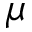Convert formula to latex. <formula><loc_0><loc_0><loc_500><loc_500>\mu</formula> 